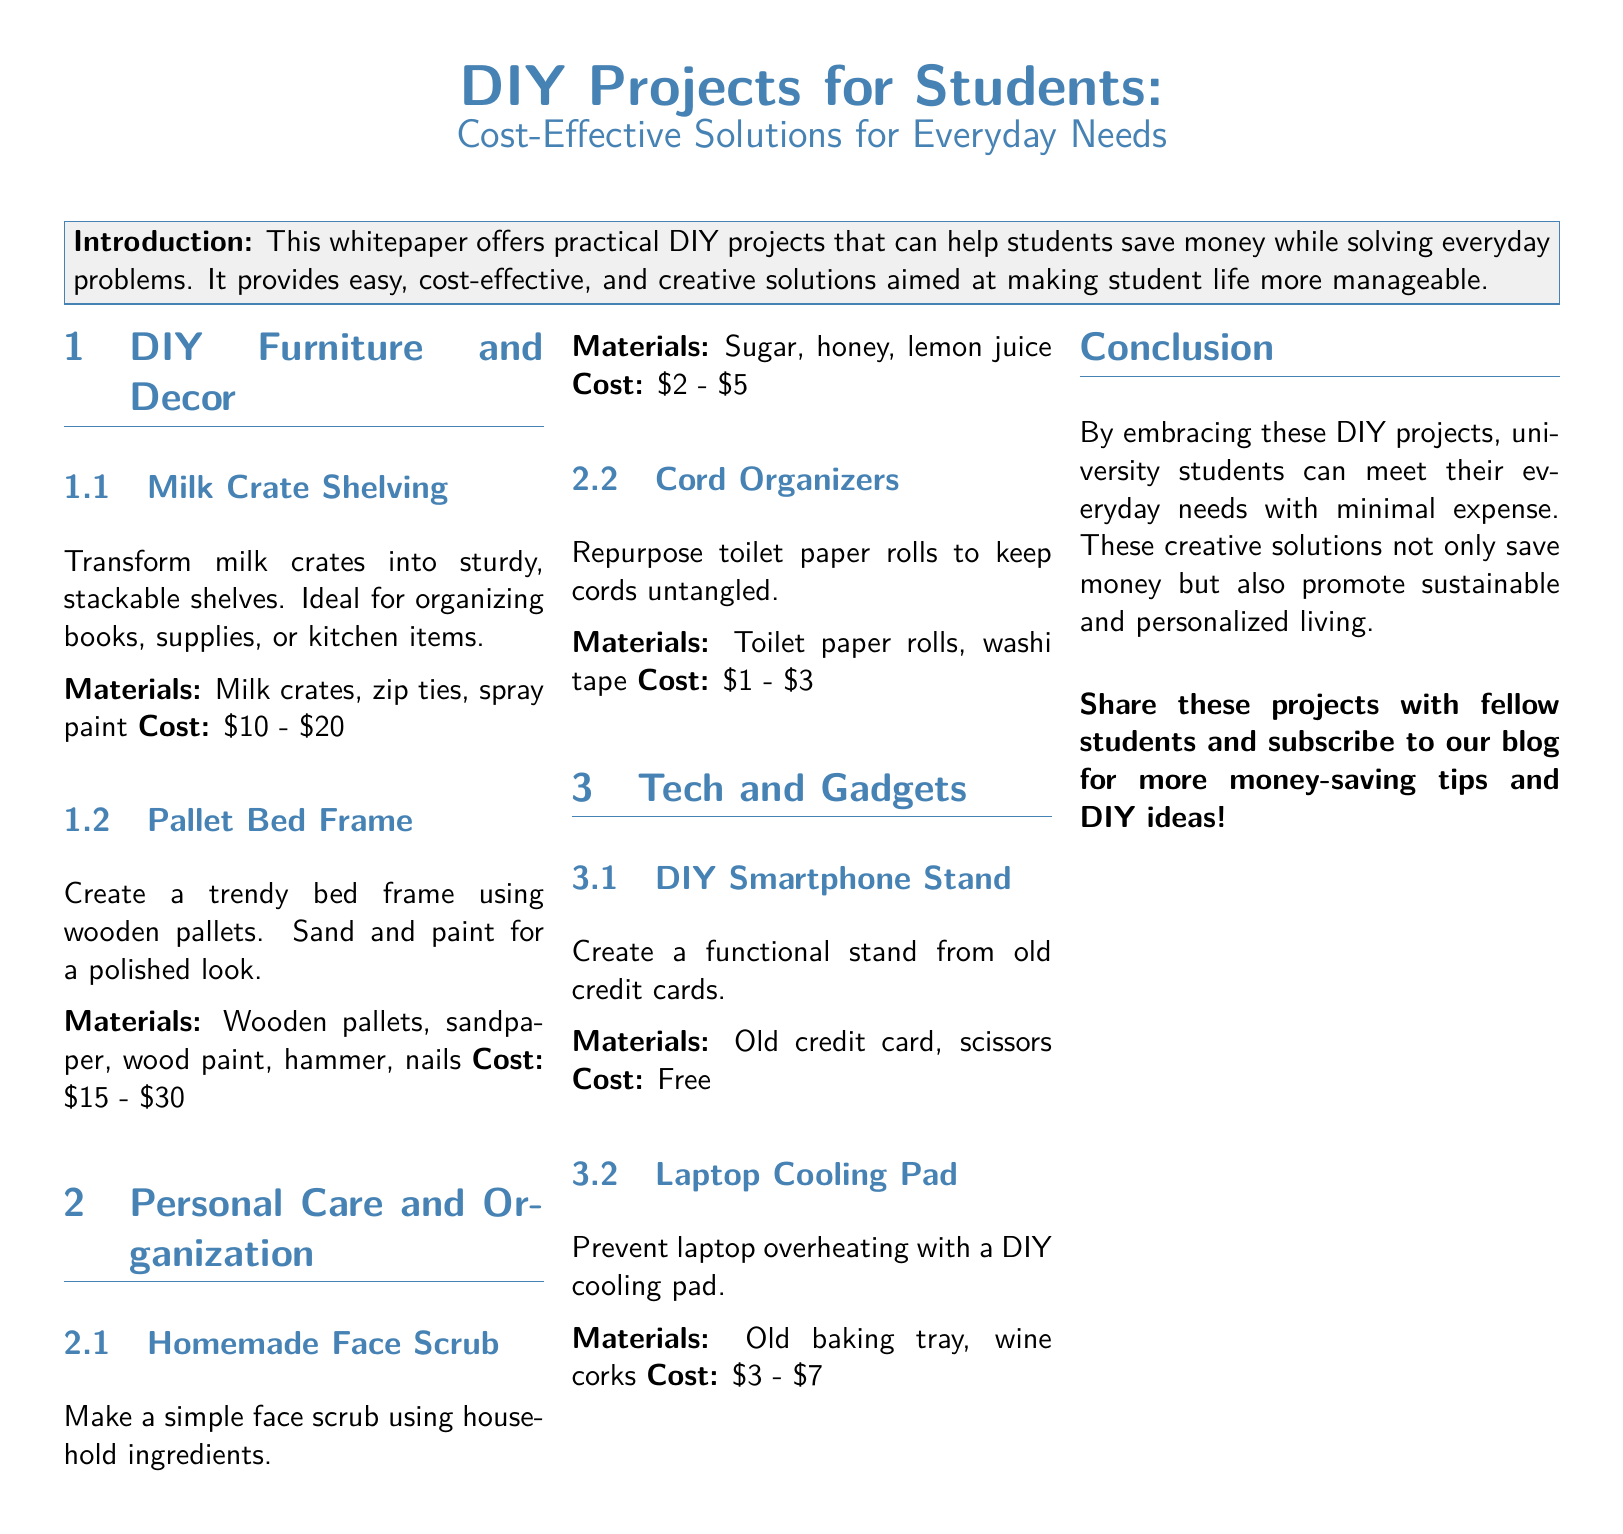What is the purpose of the whitepaper? The whitepaper offers practical DIY projects that can help students save money while solving everyday problems.
Answer: DIY projects for students to save money What is the cost range for Milk Crate Shelving? The document lists the cost for Milk Crate Shelving as between $10 and $20.
Answer: $10 - $20 What materials are needed for a Homemade Face Scrub? The materials listed for a Homemade Face Scrub are sugar, honey, and lemon juice.
Answer: Sugar, honey, lemon juice How much does a DIY Smartphone Stand cost? The document states that creating a DIY Smartphone Stand costs nothing as it uses an old credit card.
Answer: Free How many DIY projects are mentioned in the Tech and Gadgets section? The Tech and Gadgets section includes two DIY projects: DIY Smartphone Stand and Laptop Cooling Pad.
Answer: 2 What type of material is required to make Cord Organizers? The document states that Cord Organizers are made from toilet paper rolls.
Answer: Toilet paper rolls What is one benefit of embracing DIY projects mentioned in the conclusion? The conclusion emphasizes that these creative solutions save money and also promote sustainable living.
Answer: Save money Which section covers furniture and decor DIY projects? The section dedicated to furniture and decor is titled "DIY Furniture and Decor."
Answer: DIY Furniture and Decor What is the estimated cost for a Laptop Cooling Pad? The estimated cost for a Laptop Cooling Pad is between $3 and $7.
Answer: $3 - $7 